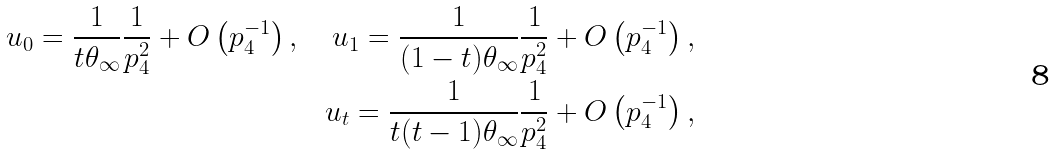<formula> <loc_0><loc_0><loc_500><loc_500>u _ { 0 } = \frac { 1 } { t \theta _ { \infty } } \frac { 1 } { p _ { 4 } ^ { 2 } } + O \left ( p _ { 4 } ^ { - 1 } \right ) , \quad u _ { 1 } = \frac { 1 } { ( 1 - t ) \theta _ { \infty } } \frac { 1 } { p _ { 4 } ^ { 2 } } + O \left ( p _ { 4 } ^ { - 1 } \right ) , \\ u _ { t } = \frac { 1 } { t ( t - 1 ) \theta _ { \infty } } \frac { 1 } { p _ { 4 } ^ { 2 } } + O \left ( p _ { 4 } ^ { - 1 } \right ) ,</formula> 